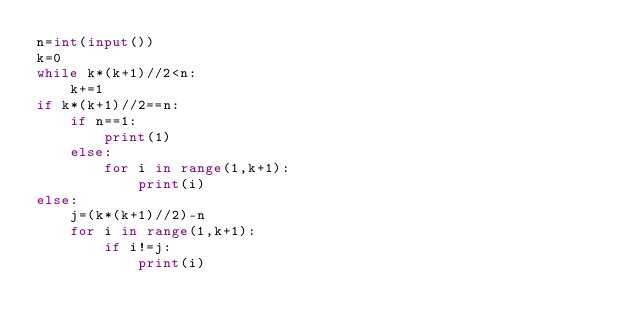Convert code to text. <code><loc_0><loc_0><loc_500><loc_500><_Python_>n=int(input())
k=0
while k*(k+1)//2<n:
    k+=1
if k*(k+1)//2==n:
    if n==1:
        print(1)
    else:
        for i in range(1,k+1):
            print(i)
else:
    j=(k*(k+1)//2)-n
    for i in range(1,k+1):
        if i!=j: 
            print(i)
    </code> 